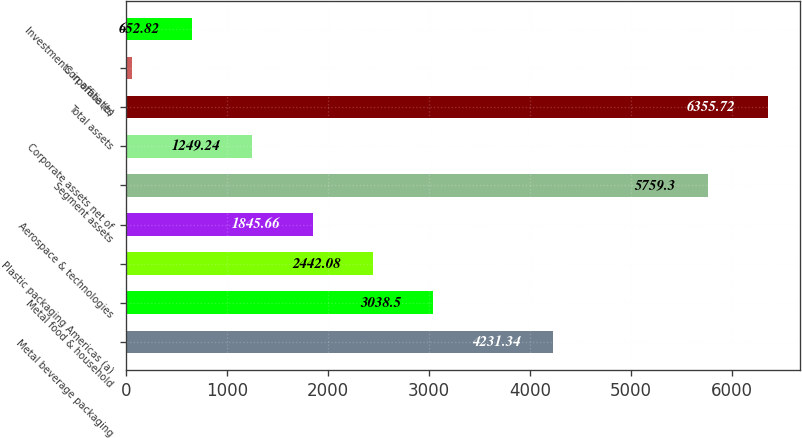<chart> <loc_0><loc_0><loc_500><loc_500><bar_chart><fcel>Metal beverage packaging<fcel>Metal food & household<fcel>Plastic packaging Americas (a)<fcel>Aerospace & technologies<fcel>Segment assets<fcel>Corporate assets net of<fcel>Total assets<fcel>Corporate (b)<fcel>Investments in affiliates<nl><fcel>4231.34<fcel>3038.5<fcel>2442.08<fcel>1845.66<fcel>5759.3<fcel>1249.24<fcel>6355.72<fcel>56.4<fcel>652.82<nl></chart> 